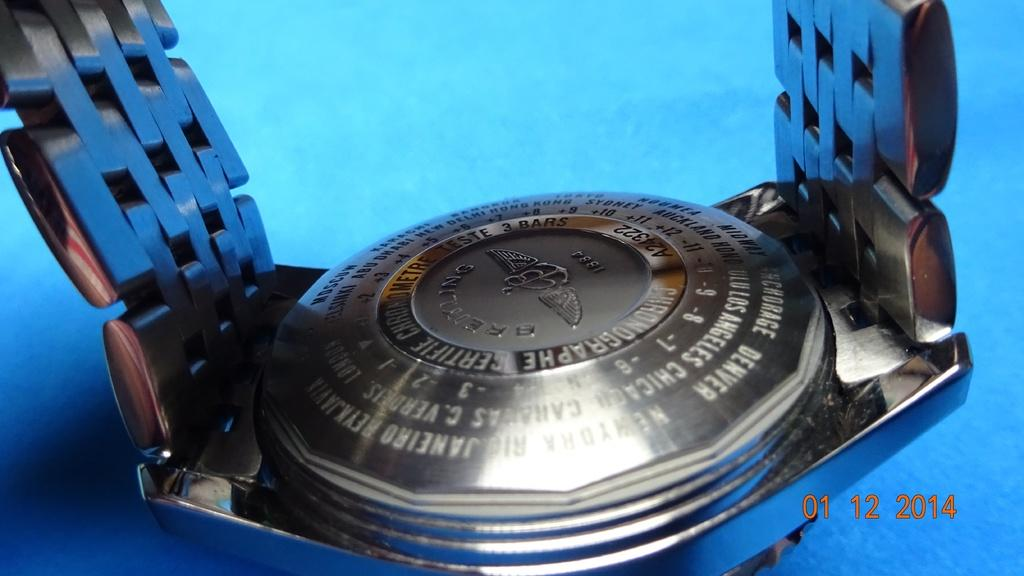<image>
Write a terse but informative summary of the picture. back of silver chronographe watch on a blue background on 01/12/2014 